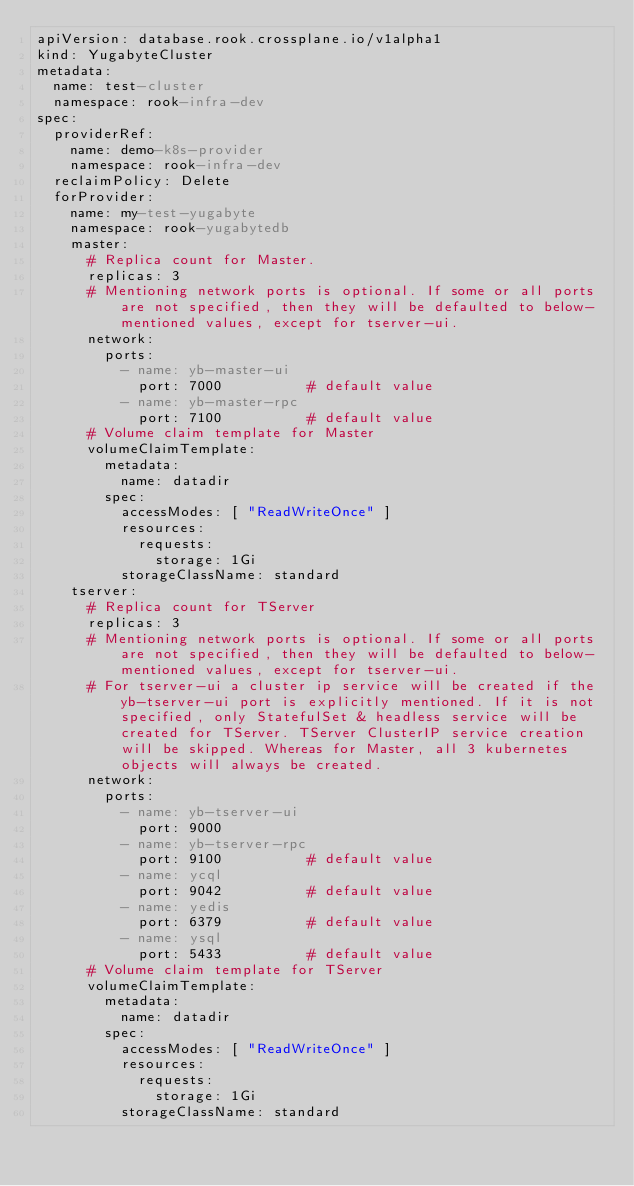<code> <loc_0><loc_0><loc_500><loc_500><_YAML_>apiVersion: database.rook.crossplane.io/v1alpha1
kind: YugabyteCluster
metadata:
  name: test-cluster
  namespace: rook-infra-dev
spec:
  providerRef:
    name: demo-k8s-provider
    namespace: rook-infra-dev
  reclaimPolicy: Delete
  forProvider:
    name: my-test-yugabyte
    namespace: rook-yugabytedb
    master:
      # Replica count for Master.
      replicas: 3
      # Mentioning network ports is optional. If some or all ports are not specified, then they will be defaulted to below-mentioned values, except for tserver-ui.
      network:
        ports:
          - name: yb-master-ui
            port: 7000          # default value
          - name: yb-master-rpc
            port: 7100          # default value
      # Volume claim template for Master
      volumeClaimTemplate:
        metadata:
          name: datadir
        spec:
          accessModes: [ "ReadWriteOnce" ]
          resources:
            requests:
              storage: 1Gi
          storageClassName: standard
    tserver:
      # Replica count for TServer
      replicas: 3
      # Mentioning network ports is optional. If some or all ports are not specified, then they will be defaulted to below-mentioned values, except for tserver-ui.
      # For tserver-ui a cluster ip service will be created if the yb-tserver-ui port is explicitly mentioned. If it is not specified, only StatefulSet & headless service will be created for TServer. TServer ClusterIP service creation will be skipped. Whereas for Master, all 3 kubernetes objects will always be created.
      network:
        ports:
          - name: yb-tserver-ui
            port: 9000
          - name: yb-tserver-rpc
            port: 9100          # default value
          - name: ycql
            port: 9042          # default value
          - name: yedis
            port: 6379          # default value
          - name: ysql
            port: 5433          # default value
      # Volume claim template for TServer
      volumeClaimTemplate:
        metadata:
          name: datadir
        spec:
          accessModes: [ "ReadWriteOnce" ]
          resources:
            requests:
              storage: 1Gi
          storageClassName: standard</code> 